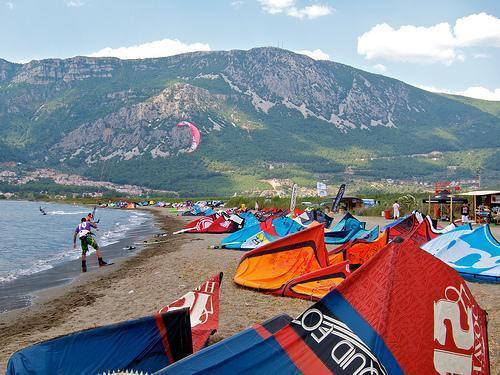How many parachute are flying?
Give a very brief answer. 1. 